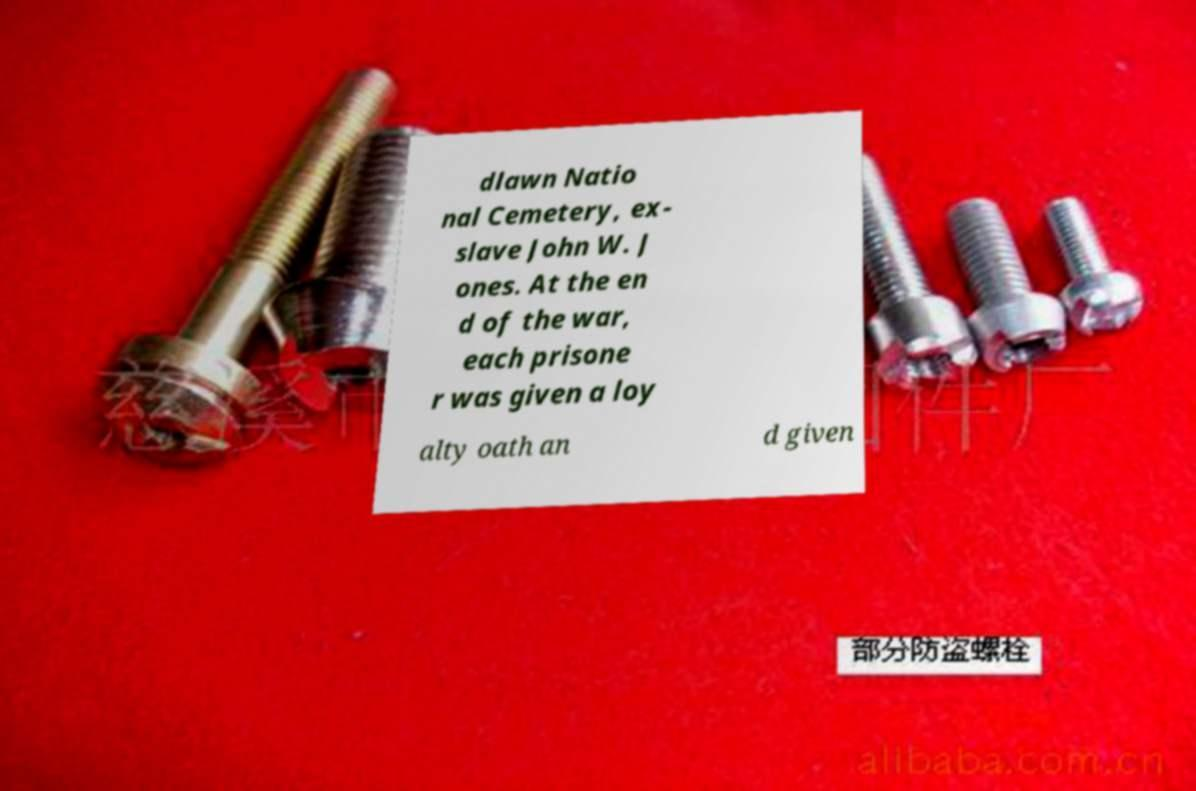Please identify and transcribe the text found in this image. dlawn Natio nal Cemetery, ex- slave John W. J ones. At the en d of the war, each prisone r was given a loy alty oath an d given 